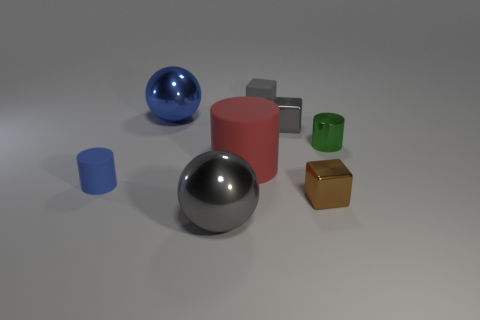Can you describe the shapes and colors seen in the image? Certainly! The image contains a variety of geometric shapes in different colors. There is a large silver sphere, a large blue sphere, a medium-sized red cylinder, a small green cylinder, a small grey cube, and a small gold cube. These shapes are organized randomly on a flat surface with a neutral grey background. 